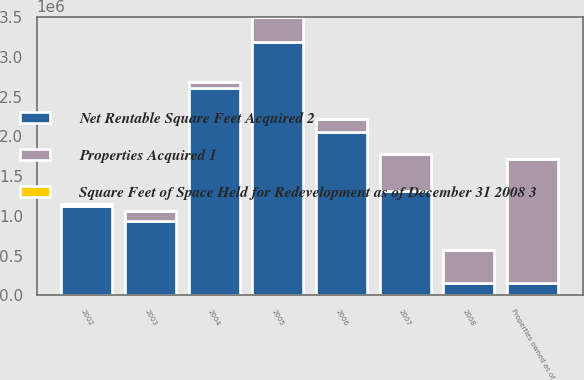Convert chart to OTSL. <chart><loc_0><loc_0><loc_500><loc_500><stacked_bar_chart><ecel><fcel>2002<fcel>2003<fcel>2004<fcel>2005<fcel>2006<fcel>2007<fcel>2008<fcel>Properties owned as of<nl><fcel>Square Feet of Space Held for Redevelopment as of December 31 2008 3<fcel>5<fcel>6<fcel>10<fcel>20<fcel>16<fcel>13<fcel>5<fcel>75<nl><fcel>Net Rentable Square Feet Acquired 2<fcel>1.12529e+06<fcel>940498<fcel>2.60986e+06<fcel>3.18619e+06<fcel>2.05983e+06<fcel>1.31776e+06<fcel>147666<fcel>147666<nl><fcel>Properties Acquired 1<fcel>19890<fcel>117862<fcel>76605<fcel>324110<fcel>161766<fcel>456797<fcel>416582<fcel>1.57361e+06<nl></chart> 